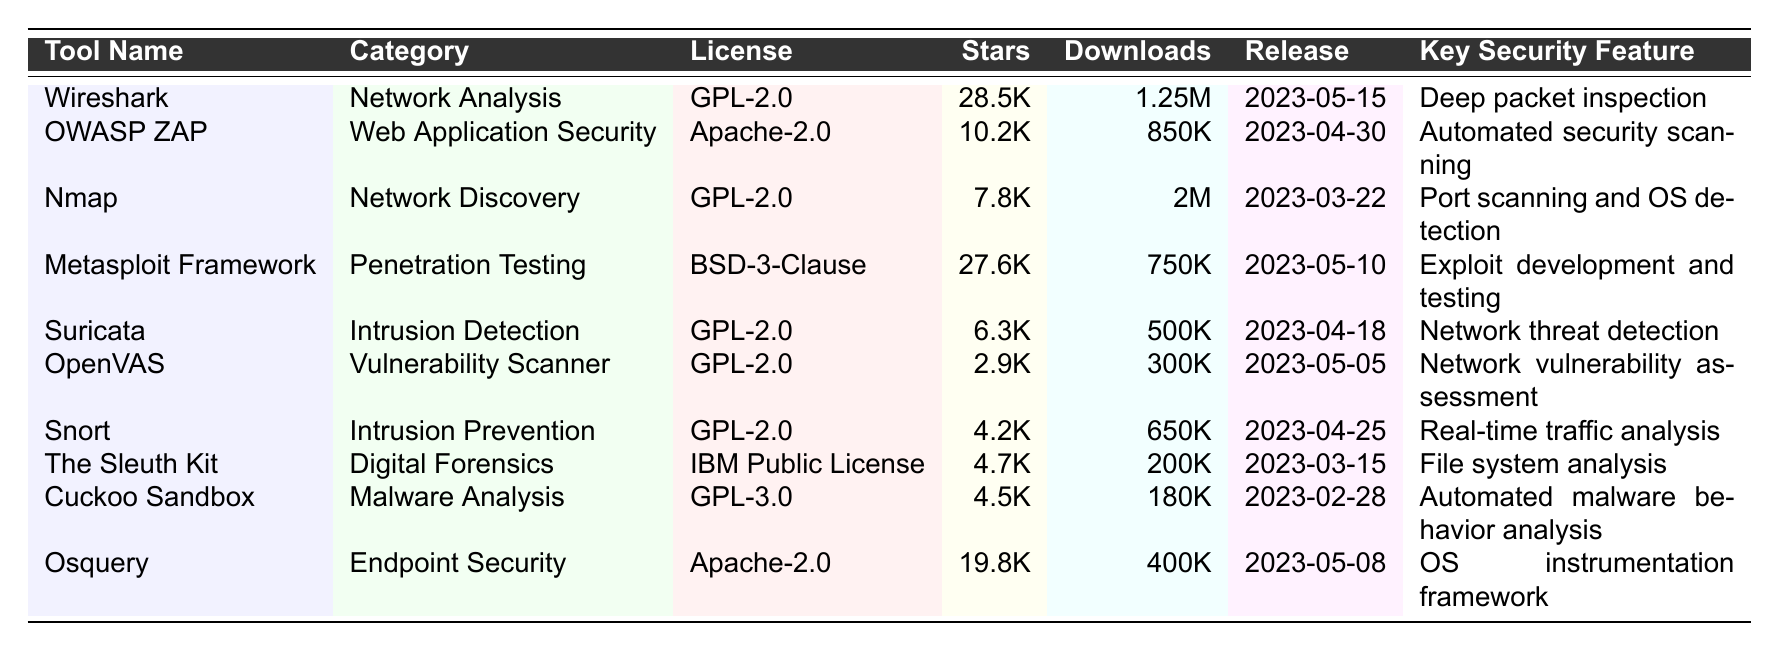What is the total number of GitHub stars for all tools listed? The GitHub stars for each tool are: Wireshark (28500), OWASP ZAP (10200), Nmap (7800), Metasploit Framework (27600), Suricata (6300), OpenVAS (2900), Snort (4200), The Sleuth Kit (4700), Cuckoo Sandbox (4500), Osquery (19800). Adding them gives: 28500 + 10200 + 7800 + 27600 + 6300 + 2900 + 4200 + 4700 + 4500 + 19800 = 102500.
Answer: 102500 Which tool has the highest number of monthly downloads? Looking at the monthly downloads, Nmap has the highest at 2000000.
Answer: Nmap Is the total number of monthly downloads among tools in the "Intrusion Detection" category greater than that of the "Network Analysis" category? The monthly downloads for Suricata (Intrusion Detection) is 500000, and for Wireshark (Network Analysis) it is 1250000. Since 500000 is not greater than 1250000, the answer is no.
Answer: No What is the average number of GitHub stars for the tools licensed under GPL-2.0? The GPL-2.0 licensed tools and their stars are: Wireshark (28500), Nmap (7800), Suricata (6300), OpenVAS (2900), Snort (4200). 
Summing them gives: 28500 + 7800 + 6300 + 2900 + 4200 = 46600. There are 5 tools, so the average is 46600 / 5 = 9320.
Answer: 9320 Does more than half of the tools have an open source license of Apache-2.0? There are 10 tools in total, with 2 tools (OWASP ZAP and Osquery) licensed under Apache-2.0. Since 2 is not more than half of 10, the answer is no.
Answer: No Which tool was released most recently and what is its key security feature? The most recent release date is 2023-05-15, which is for Wireshark. Its key security feature is Deep packet inspection.
Answer: Wireshark; Deep packet inspection How many tools are categorized under vulnerability scanning? Only one tool, OpenVAS, is categorized under vulnerability scanning.
Answer: 1 What percentage of the total GitHub stars do the tools under the "Digital Forensics" category represent? The only tool in the "Digital Forensics" category is The Sleuth Kit with 4700 stars. The total GitHub stars from all tools are 102500. The percentage is (4700 / 102500) * 100 = 4.58%.
Answer: 4.58% Which category includes the tool with the lowest number of monthly downloads? The tools and their downloads show that OpenVAS has the lowest with 300000, and it belongs to the "Vulnerability Scanner" category.
Answer: Vulnerability Scanner Are there more tools categorized as "Penetration Testing" or "Endpoint Security"? There is 1 tool in "Penetration Testing" (Metasploit Framework) and 1 in "Endpoint Security" (Osquery). Therefore, the number is the same.
Answer: Same number 